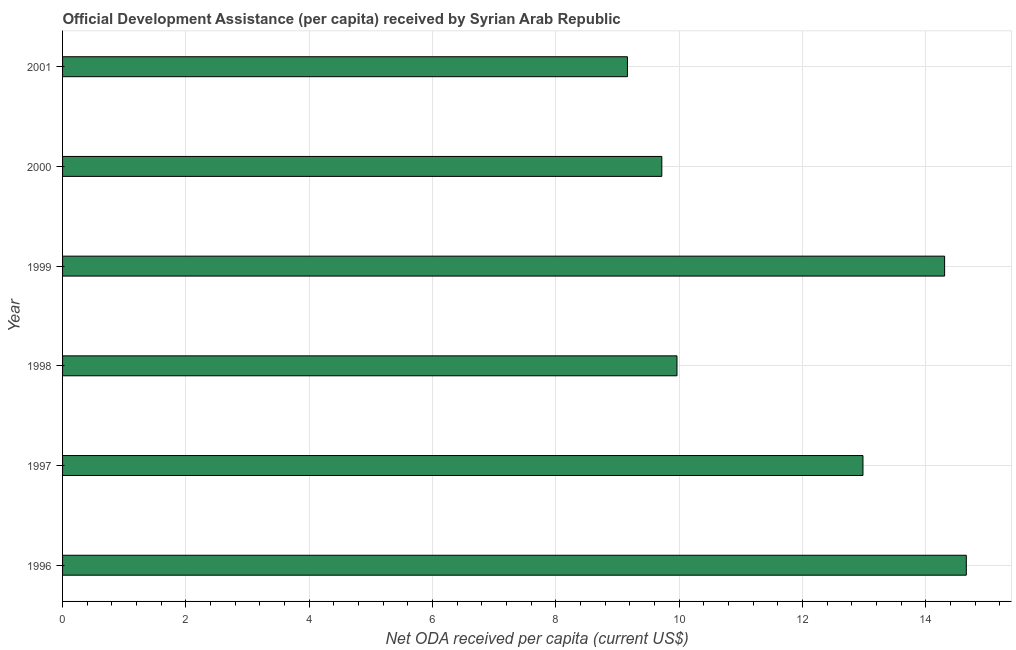Does the graph contain any zero values?
Provide a succinct answer. No. What is the title of the graph?
Your answer should be compact. Official Development Assistance (per capita) received by Syrian Arab Republic. What is the label or title of the X-axis?
Your response must be concise. Net ODA received per capita (current US$). What is the net oda received per capita in 1997?
Provide a short and direct response. 12.98. Across all years, what is the maximum net oda received per capita?
Keep it short and to the point. 14.66. Across all years, what is the minimum net oda received per capita?
Provide a short and direct response. 9.16. In which year was the net oda received per capita maximum?
Provide a succinct answer. 1996. In which year was the net oda received per capita minimum?
Ensure brevity in your answer.  2001. What is the sum of the net oda received per capita?
Give a very brief answer. 70.79. What is the difference between the net oda received per capita in 1997 and 2001?
Provide a succinct answer. 3.82. What is the average net oda received per capita per year?
Offer a terse response. 11.8. What is the median net oda received per capita?
Make the answer very short. 11.47. Do a majority of the years between 1999 and 2001 (inclusive) have net oda received per capita greater than 8.4 US$?
Make the answer very short. Yes. What is the ratio of the net oda received per capita in 1997 to that in 1999?
Give a very brief answer. 0.91. What is the difference between the highest and the second highest net oda received per capita?
Your answer should be very brief. 0.35. Is the sum of the net oda received per capita in 1999 and 2001 greater than the maximum net oda received per capita across all years?
Ensure brevity in your answer.  Yes. Are all the bars in the graph horizontal?
Your response must be concise. Yes. How many years are there in the graph?
Provide a short and direct response. 6. What is the difference between two consecutive major ticks on the X-axis?
Your answer should be compact. 2. Are the values on the major ticks of X-axis written in scientific E-notation?
Your answer should be compact. No. What is the Net ODA received per capita (current US$) of 1996?
Make the answer very short. 14.66. What is the Net ODA received per capita (current US$) of 1997?
Provide a succinct answer. 12.98. What is the Net ODA received per capita (current US$) of 1998?
Your response must be concise. 9.96. What is the Net ODA received per capita (current US$) of 1999?
Your response must be concise. 14.31. What is the Net ODA received per capita (current US$) in 2000?
Keep it short and to the point. 9.72. What is the Net ODA received per capita (current US$) in 2001?
Your answer should be compact. 9.16. What is the difference between the Net ODA received per capita (current US$) in 1996 and 1997?
Your response must be concise. 1.68. What is the difference between the Net ODA received per capita (current US$) in 1996 and 1998?
Offer a terse response. 4.69. What is the difference between the Net ODA received per capita (current US$) in 1996 and 1999?
Your answer should be compact. 0.35. What is the difference between the Net ODA received per capita (current US$) in 1996 and 2000?
Provide a succinct answer. 4.94. What is the difference between the Net ODA received per capita (current US$) in 1996 and 2001?
Your answer should be compact. 5.5. What is the difference between the Net ODA received per capita (current US$) in 1997 and 1998?
Your answer should be very brief. 3.02. What is the difference between the Net ODA received per capita (current US$) in 1997 and 1999?
Your answer should be compact. -1.32. What is the difference between the Net ODA received per capita (current US$) in 1997 and 2000?
Provide a short and direct response. 3.26. What is the difference between the Net ODA received per capita (current US$) in 1997 and 2001?
Offer a very short reply. 3.82. What is the difference between the Net ODA received per capita (current US$) in 1998 and 1999?
Offer a terse response. -4.34. What is the difference between the Net ODA received per capita (current US$) in 1998 and 2000?
Your answer should be compact. 0.25. What is the difference between the Net ODA received per capita (current US$) in 1998 and 2001?
Provide a short and direct response. 0.8. What is the difference between the Net ODA received per capita (current US$) in 1999 and 2000?
Offer a terse response. 4.59. What is the difference between the Net ODA received per capita (current US$) in 1999 and 2001?
Offer a very short reply. 5.14. What is the difference between the Net ODA received per capita (current US$) in 2000 and 2001?
Make the answer very short. 0.56. What is the ratio of the Net ODA received per capita (current US$) in 1996 to that in 1997?
Offer a very short reply. 1.13. What is the ratio of the Net ODA received per capita (current US$) in 1996 to that in 1998?
Your answer should be very brief. 1.47. What is the ratio of the Net ODA received per capita (current US$) in 1996 to that in 2000?
Keep it short and to the point. 1.51. What is the ratio of the Net ODA received per capita (current US$) in 1996 to that in 2001?
Provide a succinct answer. 1.6. What is the ratio of the Net ODA received per capita (current US$) in 1997 to that in 1998?
Make the answer very short. 1.3. What is the ratio of the Net ODA received per capita (current US$) in 1997 to that in 1999?
Your answer should be compact. 0.91. What is the ratio of the Net ODA received per capita (current US$) in 1997 to that in 2000?
Make the answer very short. 1.34. What is the ratio of the Net ODA received per capita (current US$) in 1997 to that in 2001?
Your answer should be very brief. 1.42. What is the ratio of the Net ODA received per capita (current US$) in 1998 to that in 1999?
Keep it short and to the point. 0.7. What is the ratio of the Net ODA received per capita (current US$) in 1998 to that in 2000?
Offer a very short reply. 1.02. What is the ratio of the Net ODA received per capita (current US$) in 1998 to that in 2001?
Your answer should be very brief. 1.09. What is the ratio of the Net ODA received per capita (current US$) in 1999 to that in 2000?
Make the answer very short. 1.47. What is the ratio of the Net ODA received per capita (current US$) in 1999 to that in 2001?
Provide a short and direct response. 1.56. What is the ratio of the Net ODA received per capita (current US$) in 2000 to that in 2001?
Offer a very short reply. 1.06. 